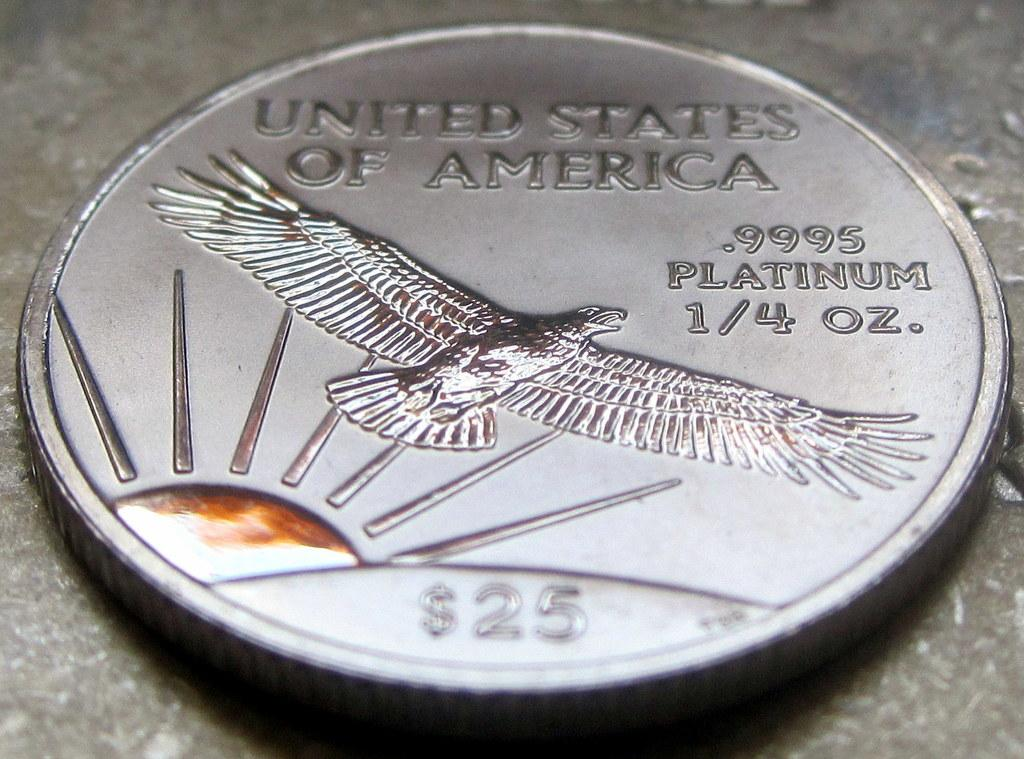<image>
Render a clear and concise summary of the photo. A coin made in the United States is made up of platinum. 